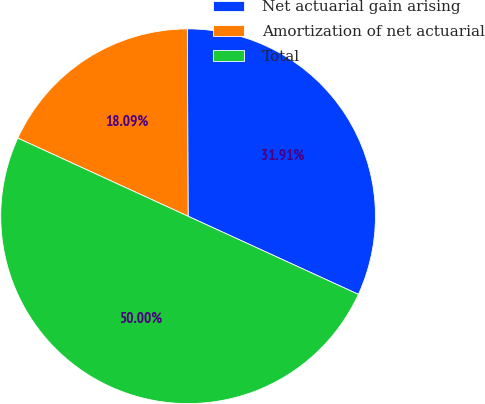Convert chart to OTSL. <chart><loc_0><loc_0><loc_500><loc_500><pie_chart><fcel>Net actuarial gain arising<fcel>Amortization of net actuarial<fcel>Total<nl><fcel>31.91%<fcel>18.09%<fcel>50.0%<nl></chart> 